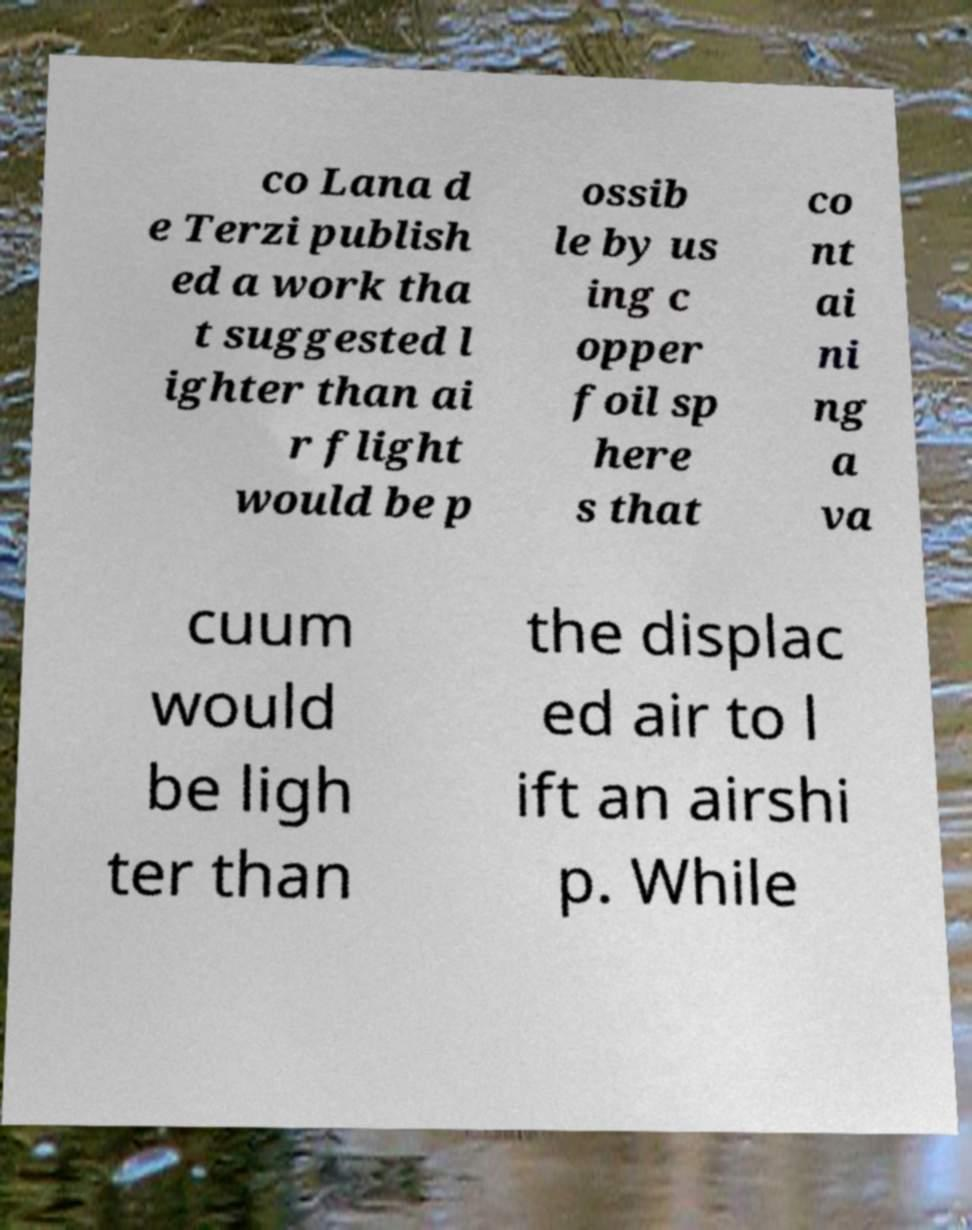Could you extract and type out the text from this image? co Lana d e Terzi publish ed a work tha t suggested l ighter than ai r flight would be p ossib le by us ing c opper foil sp here s that co nt ai ni ng a va cuum would be ligh ter than the displac ed air to l ift an airshi p. While 